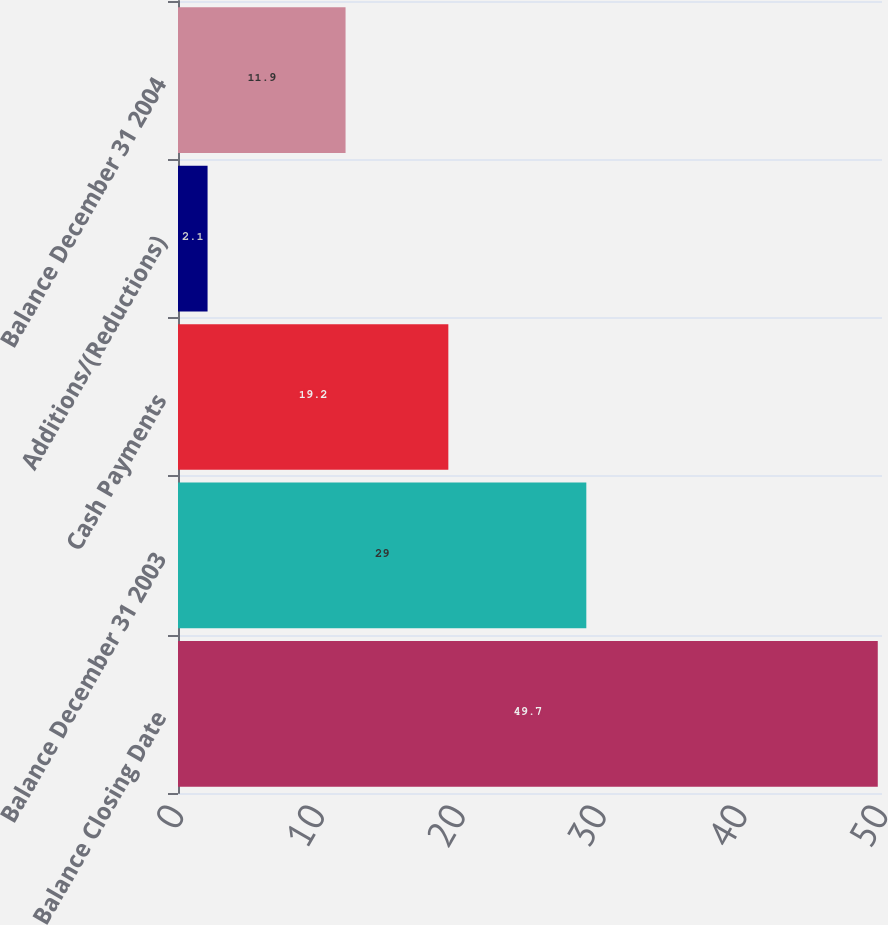Convert chart to OTSL. <chart><loc_0><loc_0><loc_500><loc_500><bar_chart><fcel>Balance Closing Date<fcel>Balance December 31 2003<fcel>Cash Payments<fcel>Additions/(Reductions)<fcel>Balance December 31 2004<nl><fcel>49.7<fcel>29<fcel>19.2<fcel>2.1<fcel>11.9<nl></chart> 